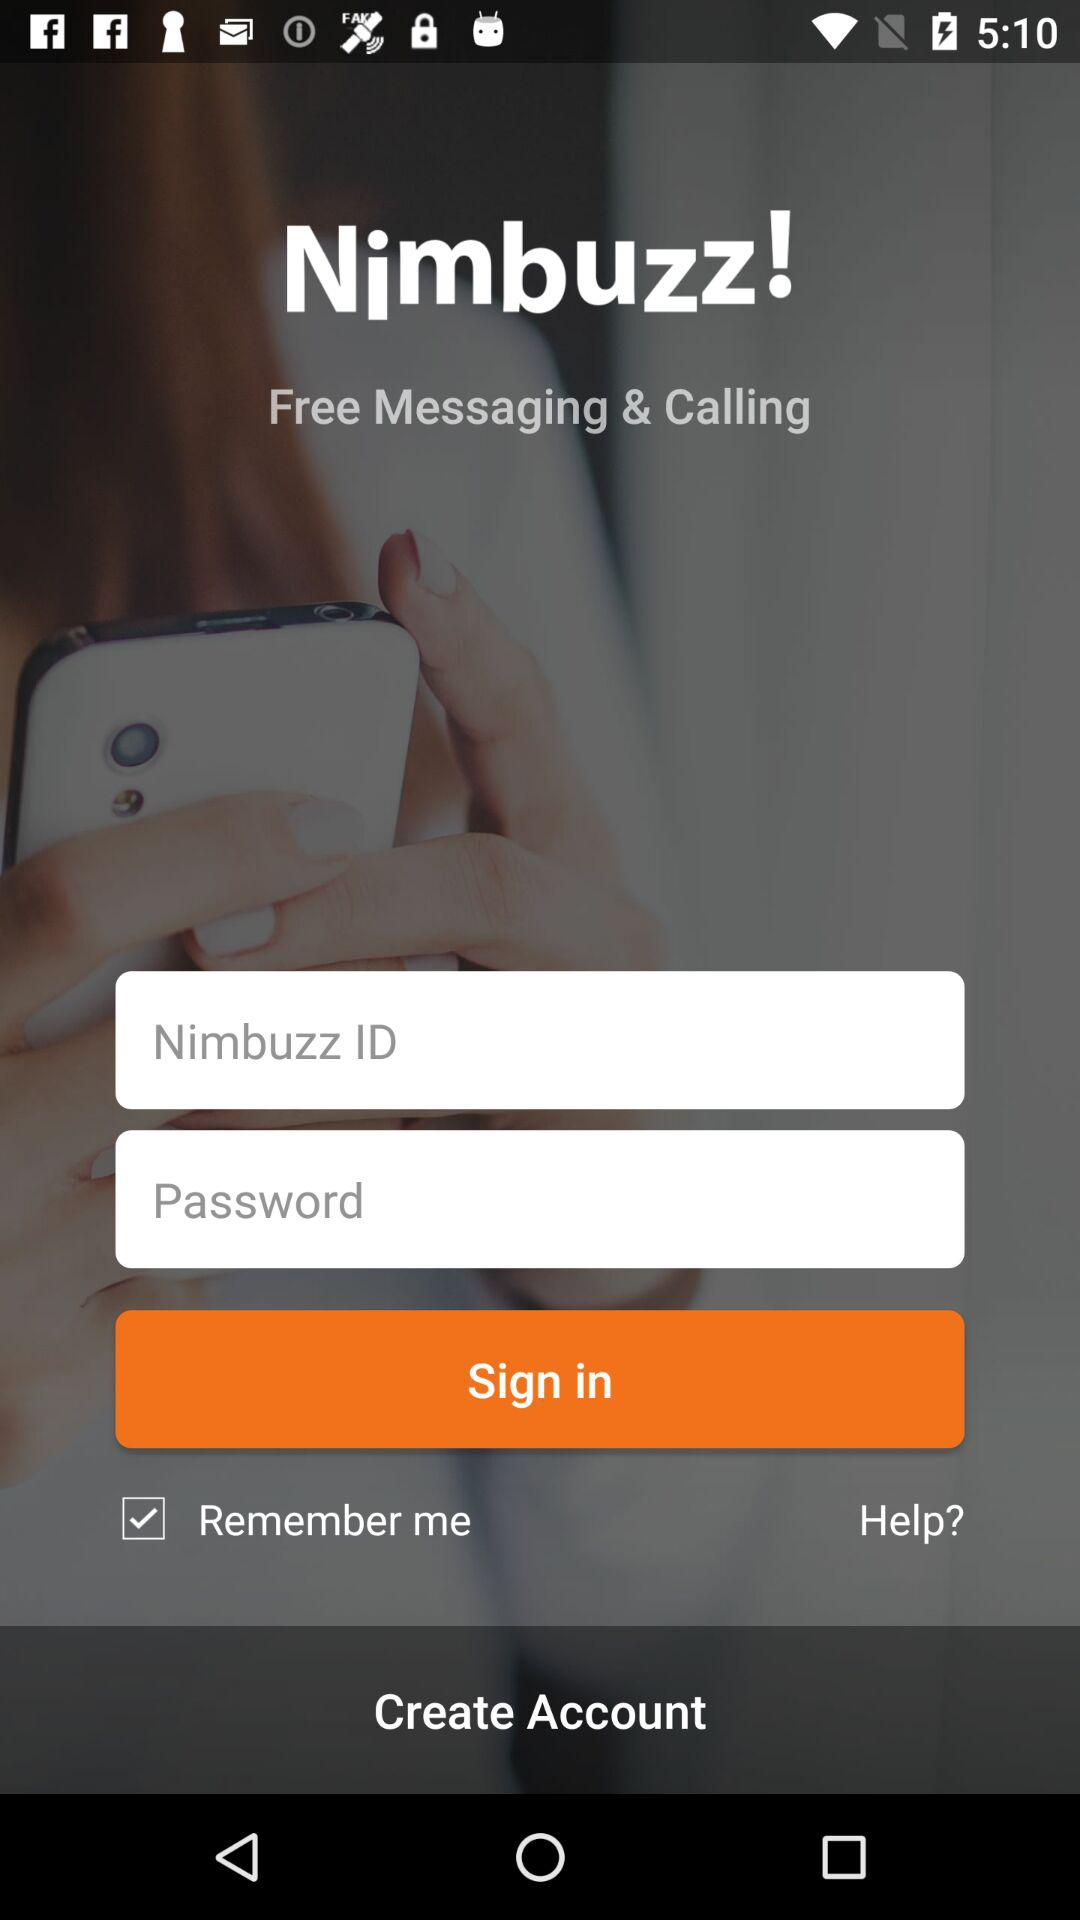Is "Remember me" checked or unchecked? "Remember me" is checked. 